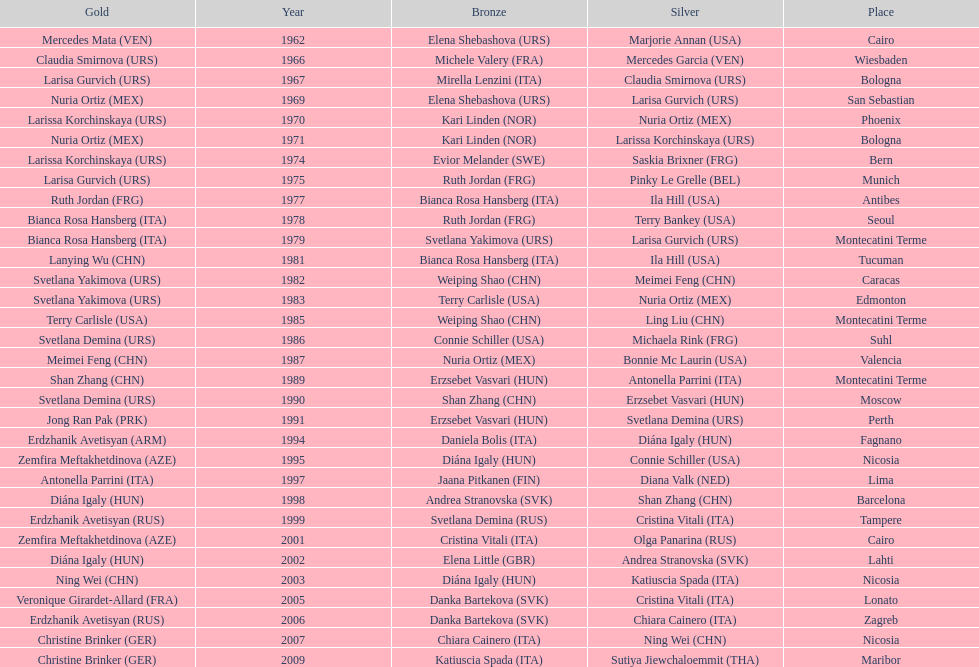What is the total of silver for cairo 0. 